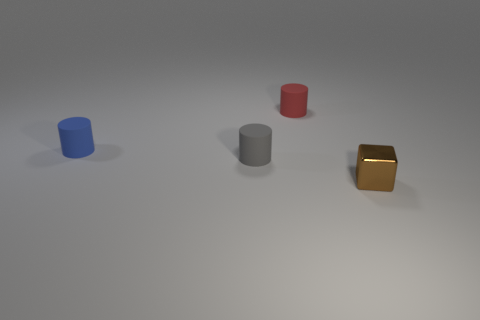Is the shape of the small gray rubber object the same as the tiny blue thing?
Your answer should be compact. Yes. What size is the red thing that is the same shape as the blue thing?
Offer a terse response. Small. What is the size of the thing that is both in front of the blue matte cylinder and to the left of the brown metallic thing?
Ensure brevity in your answer.  Small. How many other objects are the same color as the cube?
Offer a terse response. 0. What number of objects are tiny gray rubber things or small cylinders on the left side of the red object?
Ensure brevity in your answer.  2. There is a rubber object in front of the blue cylinder; what color is it?
Make the answer very short. Gray. What shape is the gray thing?
Offer a terse response. Cylinder. What is the object that is behind the blue rubber thing that is left of the gray rubber object made of?
Provide a succinct answer. Rubber. How many other things are there of the same material as the small blue thing?
Provide a short and direct response. 2. What material is the red object that is the same size as the blue rubber object?
Give a very brief answer. Rubber. 